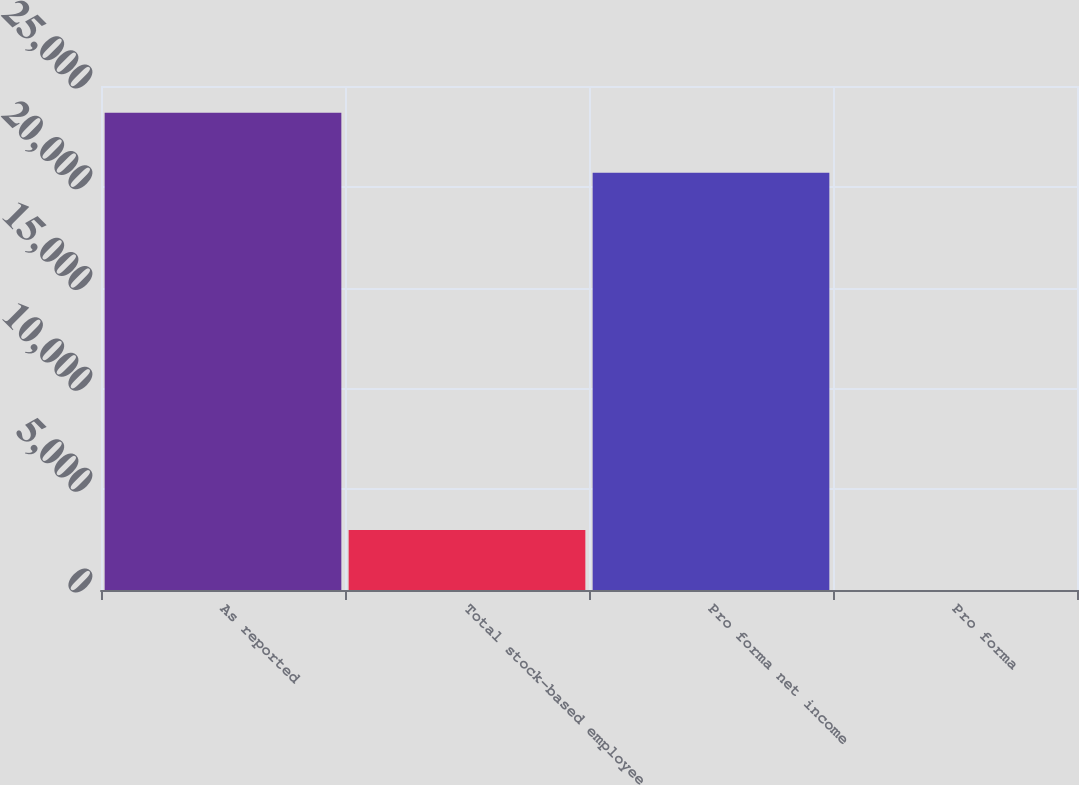Convert chart to OTSL. <chart><loc_0><loc_0><loc_500><loc_500><bar_chart><fcel>As reported<fcel>Total stock-based employee<fcel>Pro forma net income<fcel>Pro forma<nl><fcel>23668<fcel>2973<fcel>20695<fcel>0.72<nl></chart> 